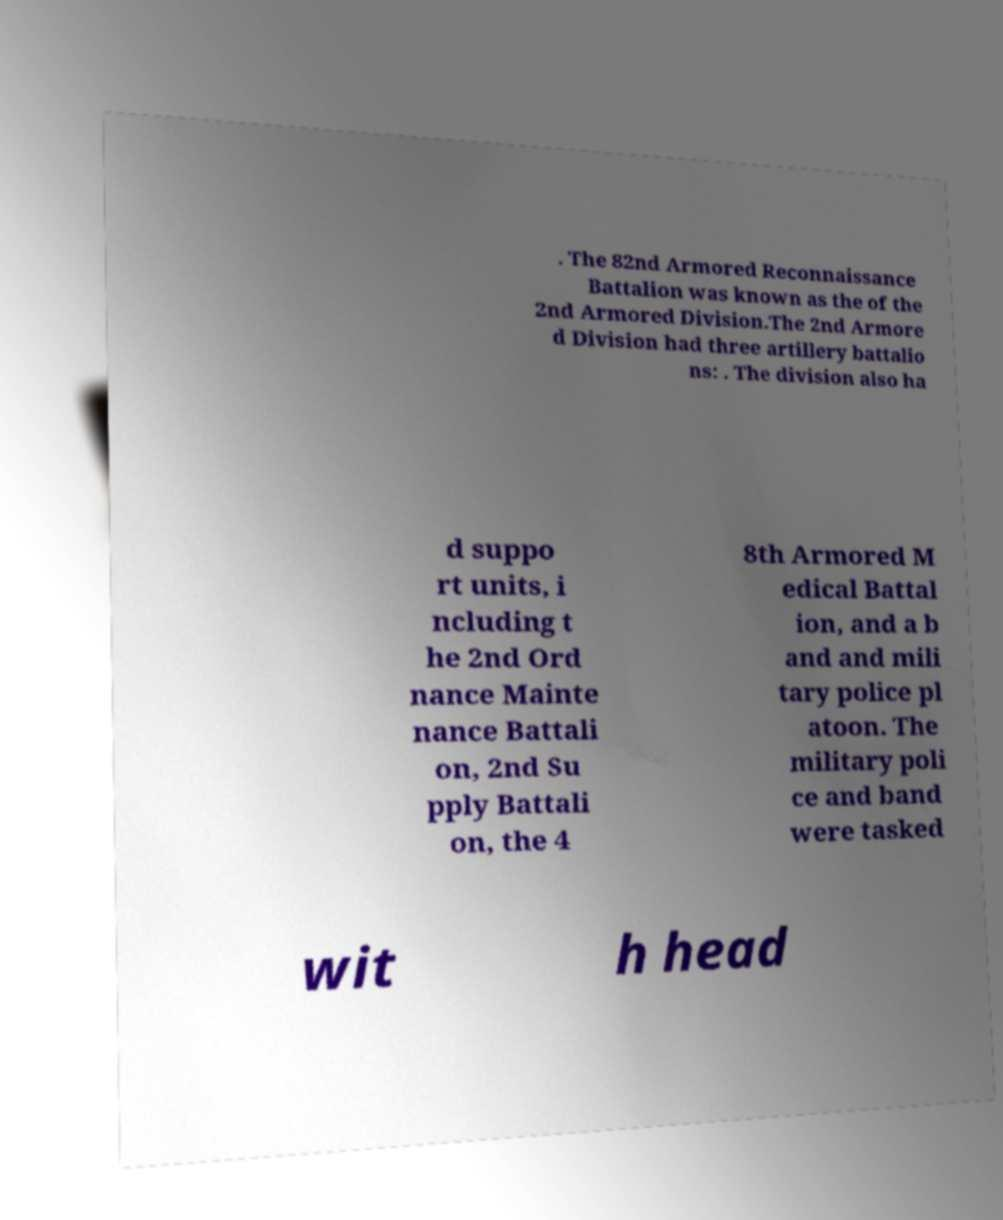Please identify and transcribe the text found in this image. . The 82nd Armored Reconnaissance Battalion was known as the of the 2nd Armored Division.The 2nd Armore d Division had three artillery battalio ns: . The division also ha d suppo rt units, i ncluding t he 2nd Ord nance Mainte nance Battali on, 2nd Su pply Battali on, the 4 8th Armored M edical Battal ion, and a b and and mili tary police pl atoon. The military poli ce and band were tasked wit h head 